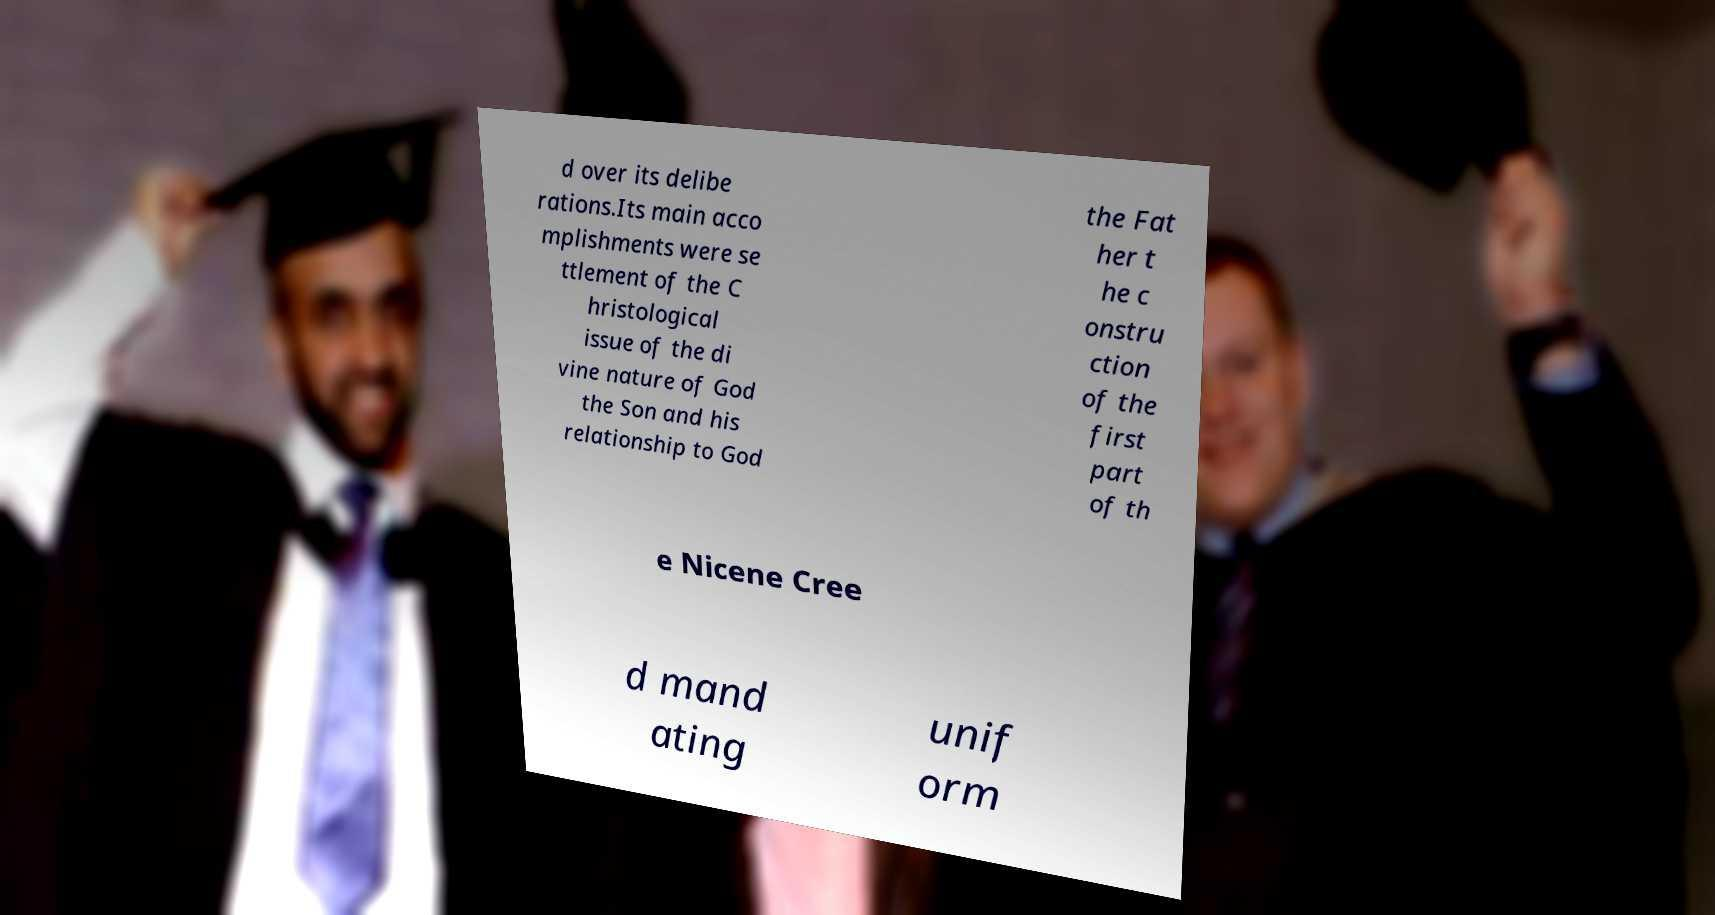Can you accurately transcribe the text from the provided image for me? d over its delibe rations.Its main acco mplishments were se ttlement of the C hristological issue of the di vine nature of God the Son and his relationship to God the Fat her t he c onstru ction of the first part of th e Nicene Cree d mand ating unif orm 